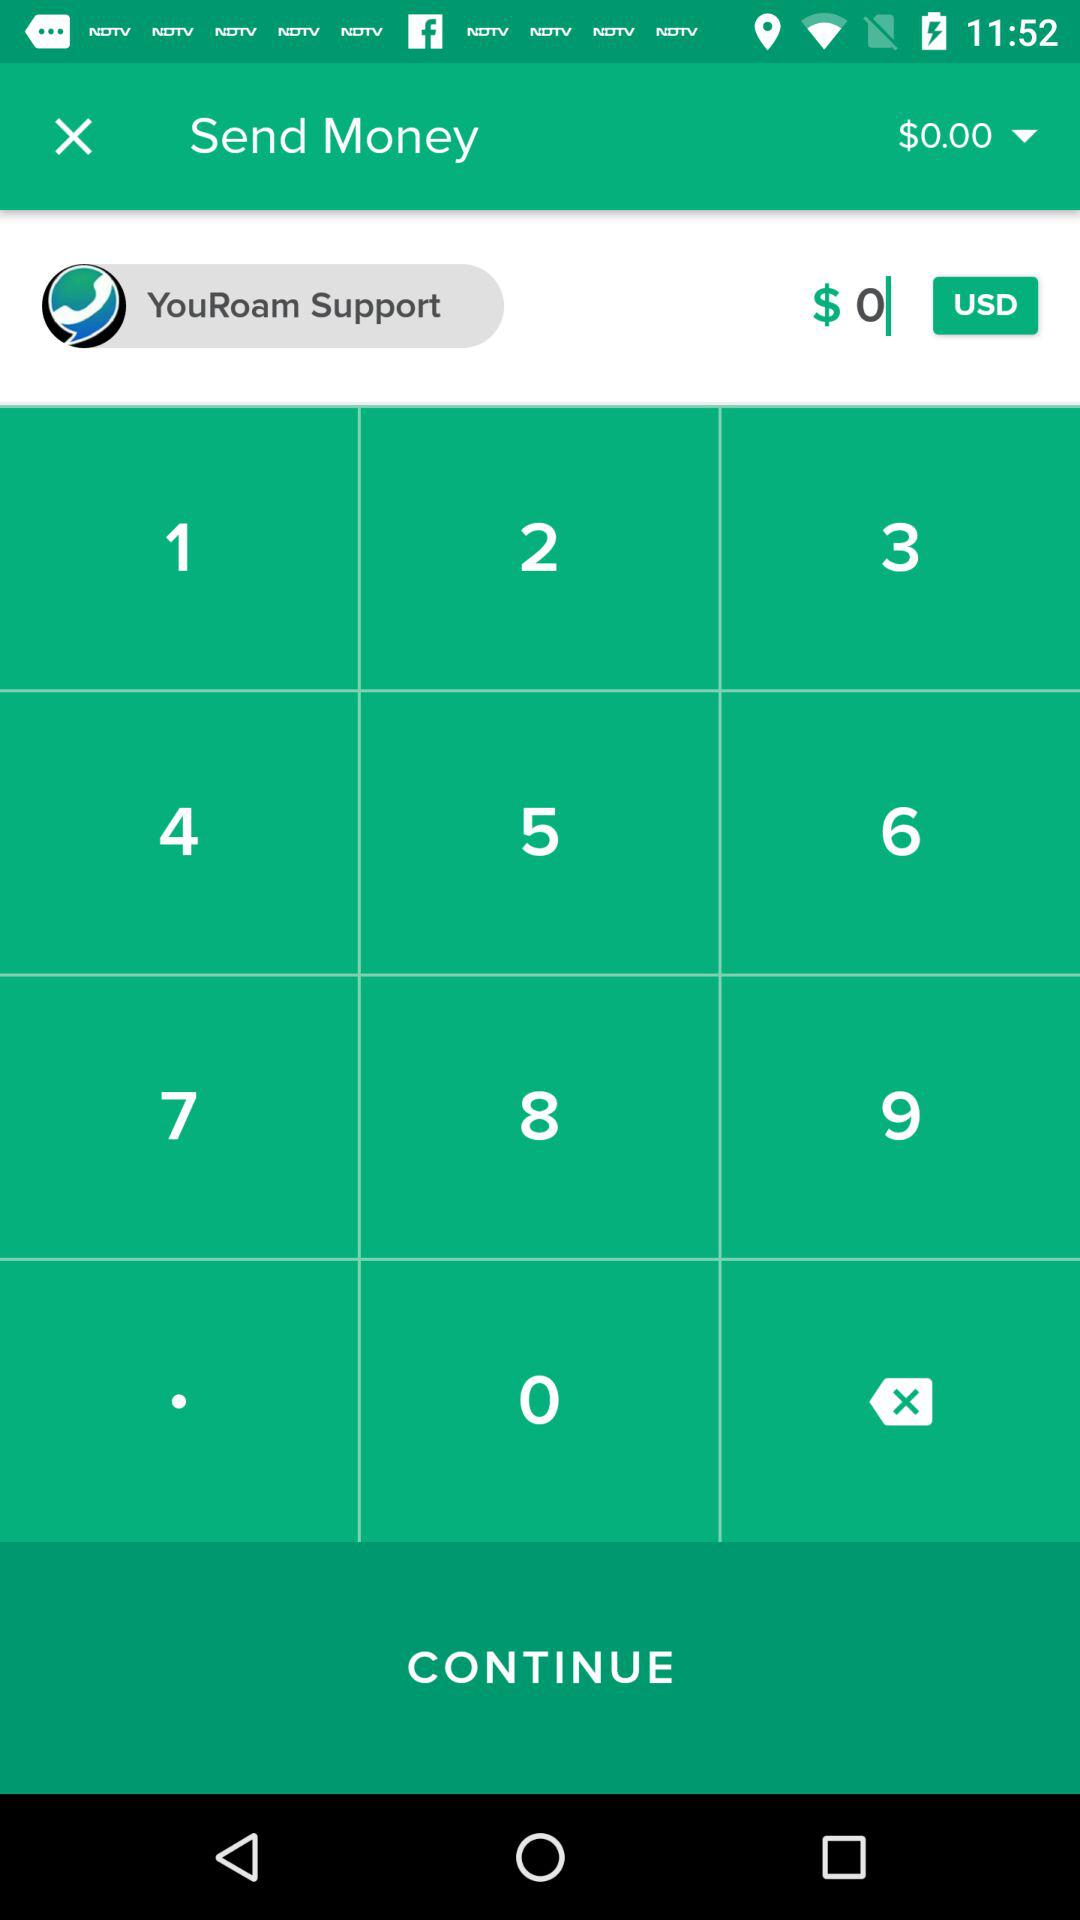What is the amount? The amount is $0.00. 